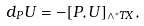Convert formula to latex. <formula><loc_0><loc_0><loc_500><loc_500>d _ { P } U = - [ P , U ] _ { \wedge ^ { * } T X } ,</formula> 